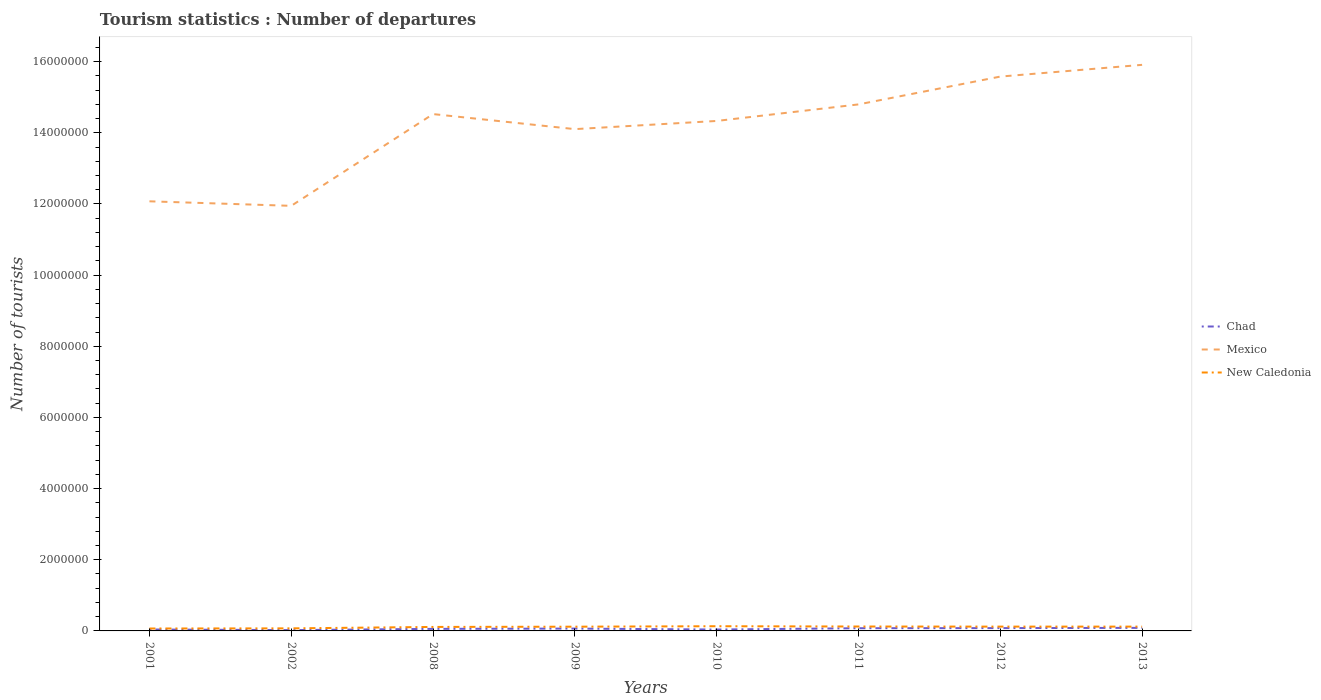How many different coloured lines are there?
Offer a very short reply. 3. Does the line corresponding to Mexico intersect with the line corresponding to New Caledonia?
Your response must be concise. No. Across all years, what is the maximum number of tourist departures in Mexico?
Offer a terse response. 1.19e+07. What is the total number of tourist departures in Mexico in the graph?
Offer a terse response. 4.23e+05. What is the difference between the highest and the second highest number of tourist departures in New Caledonia?
Make the answer very short. 6.40e+04. What is the difference between the highest and the lowest number of tourist departures in Mexico?
Your response must be concise. 5. What is the difference between two consecutive major ticks on the Y-axis?
Provide a short and direct response. 2.00e+06. How are the legend labels stacked?
Provide a short and direct response. Vertical. What is the title of the graph?
Your answer should be compact. Tourism statistics : Number of departures. Does "Aruba" appear as one of the legend labels in the graph?
Offer a very short reply. No. What is the label or title of the Y-axis?
Keep it short and to the point. Number of tourists. What is the Number of tourists in Mexico in 2001?
Provide a succinct answer. 1.21e+07. What is the Number of tourists of New Caledonia in 2001?
Offer a very short reply. 6.80e+04. What is the Number of tourists in Chad in 2002?
Keep it short and to the point. 2.30e+04. What is the Number of tourists of Mexico in 2002?
Your answer should be very brief. 1.19e+07. What is the Number of tourists in New Caledonia in 2002?
Your answer should be compact. 7.20e+04. What is the Number of tourists in Chad in 2008?
Your response must be concise. 5.80e+04. What is the Number of tourists in Mexico in 2008?
Your response must be concise. 1.45e+07. What is the Number of tourists of New Caledonia in 2008?
Provide a short and direct response. 1.12e+05. What is the Number of tourists of Chad in 2009?
Your answer should be compact. 6.60e+04. What is the Number of tourists in Mexico in 2009?
Make the answer very short. 1.41e+07. What is the Number of tourists of New Caledonia in 2009?
Your answer should be very brief. 1.19e+05. What is the Number of tourists in Chad in 2010?
Provide a succinct answer. 3.90e+04. What is the Number of tourists of Mexico in 2010?
Your answer should be compact. 1.43e+07. What is the Number of tourists of New Caledonia in 2010?
Your response must be concise. 1.32e+05. What is the Number of tourists in Chad in 2011?
Make the answer very short. 7.60e+04. What is the Number of tourists in Mexico in 2011?
Offer a very short reply. 1.48e+07. What is the Number of tourists in New Caledonia in 2011?
Provide a short and direct response. 1.24e+05. What is the Number of tourists of Chad in 2012?
Offer a very short reply. 7.90e+04. What is the Number of tourists of Mexico in 2012?
Provide a short and direct response. 1.56e+07. What is the Number of tourists in New Caledonia in 2012?
Provide a succinct answer. 1.21e+05. What is the Number of tourists in Chad in 2013?
Ensure brevity in your answer.  8.60e+04. What is the Number of tourists of Mexico in 2013?
Your answer should be very brief. 1.59e+07. What is the Number of tourists in New Caledonia in 2013?
Provide a succinct answer. 1.21e+05. Across all years, what is the maximum Number of tourists in Chad?
Offer a very short reply. 8.60e+04. Across all years, what is the maximum Number of tourists of Mexico?
Offer a terse response. 1.59e+07. Across all years, what is the maximum Number of tourists in New Caledonia?
Provide a succinct answer. 1.32e+05. Across all years, what is the minimum Number of tourists in Chad?
Provide a short and direct response. 2.30e+04. Across all years, what is the minimum Number of tourists in Mexico?
Ensure brevity in your answer.  1.19e+07. Across all years, what is the minimum Number of tourists in New Caledonia?
Make the answer very short. 6.80e+04. What is the total Number of tourists of Chad in the graph?
Offer a terse response. 4.67e+05. What is the total Number of tourists of Mexico in the graph?
Ensure brevity in your answer.  1.13e+08. What is the total Number of tourists in New Caledonia in the graph?
Provide a short and direct response. 8.69e+05. What is the difference between the Number of tourists in Chad in 2001 and that in 2002?
Make the answer very short. 1.70e+04. What is the difference between the Number of tourists in Mexico in 2001 and that in 2002?
Offer a terse response. 1.27e+05. What is the difference between the Number of tourists in New Caledonia in 2001 and that in 2002?
Provide a succinct answer. -4000. What is the difference between the Number of tourists of Chad in 2001 and that in 2008?
Provide a short and direct response. -1.80e+04. What is the difference between the Number of tourists of Mexico in 2001 and that in 2008?
Provide a succinct answer. -2.45e+06. What is the difference between the Number of tourists in New Caledonia in 2001 and that in 2008?
Provide a succinct answer. -4.40e+04. What is the difference between the Number of tourists in Chad in 2001 and that in 2009?
Offer a terse response. -2.60e+04. What is the difference between the Number of tourists in Mexico in 2001 and that in 2009?
Ensure brevity in your answer.  -2.03e+06. What is the difference between the Number of tourists in New Caledonia in 2001 and that in 2009?
Provide a short and direct response. -5.10e+04. What is the difference between the Number of tourists of Mexico in 2001 and that in 2010?
Keep it short and to the point. -2.26e+06. What is the difference between the Number of tourists in New Caledonia in 2001 and that in 2010?
Provide a short and direct response. -6.40e+04. What is the difference between the Number of tourists in Chad in 2001 and that in 2011?
Ensure brevity in your answer.  -3.60e+04. What is the difference between the Number of tourists in Mexico in 2001 and that in 2011?
Your answer should be very brief. -2.72e+06. What is the difference between the Number of tourists of New Caledonia in 2001 and that in 2011?
Ensure brevity in your answer.  -5.60e+04. What is the difference between the Number of tourists in Chad in 2001 and that in 2012?
Give a very brief answer. -3.90e+04. What is the difference between the Number of tourists of Mexico in 2001 and that in 2012?
Make the answer very short. -3.51e+06. What is the difference between the Number of tourists in New Caledonia in 2001 and that in 2012?
Give a very brief answer. -5.30e+04. What is the difference between the Number of tourists in Chad in 2001 and that in 2013?
Offer a very short reply. -4.60e+04. What is the difference between the Number of tourists of Mexico in 2001 and that in 2013?
Your answer should be very brief. -3.84e+06. What is the difference between the Number of tourists of New Caledonia in 2001 and that in 2013?
Offer a terse response. -5.30e+04. What is the difference between the Number of tourists of Chad in 2002 and that in 2008?
Your response must be concise. -3.50e+04. What is the difference between the Number of tourists of Mexico in 2002 and that in 2008?
Ensure brevity in your answer.  -2.58e+06. What is the difference between the Number of tourists in New Caledonia in 2002 and that in 2008?
Your response must be concise. -4.00e+04. What is the difference between the Number of tourists of Chad in 2002 and that in 2009?
Your answer should be compact. -4.30e+04. What is the difference between the Number of tourists of Mexico in 2002 and that in 2009?
Keep it short and to the point. -2.16e+06. What is the difference between the Number of tourists of New Caledonia in 2002 and that in 2009?
Offer a terse response. -4.70e+04. What is the difference between the Number of tourists of Chad in 2002 and that in 2010?
Keep it short and to the point. -1.60e+04. What is the difference between the Number of tourists in Mexico in 2002 and that in 2010?
Your answer should be compact. -2.39e+06. What is the difference between the Number of tourists in New Caledonia in 2002 and that in 2010?
Offer a terse response. -6.00e+04. What is the difference between the Number of tourists in Chad in 2002 and that in 2011?
Keep it short and to the point. -5.30e+04. What is the difference between the Number of tourists in Mexico in 2002 and that in 2011?
Give a very brief answer. -2.85e+06. What is the difference between the Number of tourists in New Caledonia in 2002 and that in 2011?
Make the answer very short. -5.20e+04. What is the difference between the Number of tourists in Chad in 2002 and that in 2012?
Ensure brevity in your answer.  -5.60e+04. What is the difference between the Number of tourists of Mexico in 2002 and that in 2012?
Ensure brevity in your answer.  -3.63e+06. What is the difference between the Number of tourists in New Caledonia in 2002 and that in 2012?
Give a very brief answer. -4.90e+04. What is the difference between the Number of tourists in Chad in 2002 and that in 2013?
Ensure brevity in your answer.  -6.30e+04. What is the difference between the Number of tourists of Mexico in 2002 and that in 2013?
Your answer should be compact. -3.96e+06. What is the difference between the Number of tourists in New Caledonia in 2002 and that in 2013?
Offer a terse response. -4.90e+04. What is the difference between the Number of tourists in Chad in 2008 and that in 2009?
Make the answer very short. -8000. What is the difference between the Number of tourists of Mexico in 2008 and that in 2009?
Give a very brief answer. 4.23e+05. What is the difference between the Number of tourists of New Caledonia in 2008 and that in 2009?
Keep it short and to the point. -7000. What is the difference between the Number of tourists in Chad in 2008 and that in 2010?
Provide a short and direct response. 1.90e+04. What is the difference between the Number of tourists in Mexico in 2008 and that in 2010?
Give a very brief answer. 1.93e+05. What is the difference between the Number of tourists of New Caledonia in 2008 and that in 2010?
Keep it short and to the point. -2.00e+04. What is the difference between the Number of tourists of Chad in 2008 and that in 2011?
Make the answer very short. -1.80e+04. What is the difference between the Number of tourists of Mexico in 2008 and that in 2011?
Make the answer very short. -2.72e+05. What is the difference between the Number of tourists in New Caledonia in 2008 and that in 2011?
Provide a short and direct response. -1.20e+04. What is the difference between the Number of tourists of Chad in 2008 and that in 2012?
Your response must be concise. -2.10e+04. What is the difference between the Number of tourists in Mexico in 2008 and that in 2012?
Ensure brevity in your answer.  -1.05e+06. What is the difference between the Number of tourists in New Caledonia in 2008 and that in 2012?
Provide a short and direct response. -9000. What is the difference between the Number of tourists in Chad in 2008 and that in 2013?
Provide a succinct answer. -2.80e+04. What is the difference between the Number of tourists of Mexico in 2008 and that in 2013?
Keep it short and to the point. -1.38e+06. What is the difference between the Number of tourists of New Caledonia in 2008 and that in 2013?
Offer a very short reply. -9000. What is the difference between the Number of tourists of Chad in 2009 and that in 2010?
Provide a short and direct response. 2.70e+04. What is the difference between the Number of tourists of Mexico in 2009 and that in 2010?
Ensure brevity in your answer.  -2.30e+05. What is the difference between the Number of tourists in New Caledonia in 2009 and that in 2010?
Provide a succinct answer. -1.30e+04. What is the difference between the Number of tourists in Chad in 2009 and that in 2011?
Provide a succinct answer. -10000. What is the difference between the Number of tourists of Mexico in 2009 and that in 2011?
Your answer should be compact. -6.95e+05. What is the difference between the Number of tourists in New Caledonia in 2009 and that in 2011?
Your answer should be compact. -5000. What is the difference between the Number of tourists of Chad in 2009 and that in 2012?
Make the answer very short. -1.30e+04. What is the difference between the Number of tourists in Mexico in 2009 and that in 2012?
Keep it short and to the point. -1.48e+06. What is the difference between the Number of tourists of New Caledonia in 2009 and that in 2012?
Your answer should be compact. -2000. What is the difference between the Number of tourists in Chad in 2009 and that in 2013?
Ensure brevity in your answer.  -2.00e+04. What is the difference between the Number of tourists of Mexico in 2009 and that in 2013?
Make the answer very short. -1.81e+06. What is the difference between the Number of tourists in New Caledonia in 2009 and that in 2013?
Make the answer very short. -2000. What is the difference between the Number of tourists in Chad in 2010 and that in 2011?
Your answer should be compact. -3.70e+04. What is the difference between the Number of tourists in Mexico in 2010 and that in 2011?
Your answer should be compact. -4.65e+05. What is the difference between the Number of tourists of New Caledonia in 2010 and that in 2011?
Give a very brief answer. 8000. What is the difference between the Number of tourists in Chad in 2010 and that in 2012?
Your answer should be very brief. -4.00e+04. What is the difference between the Number of tourists in Mexico in 2010 and that in 2012?
Offer a terse response. -1.25e+06. What is the difference between the Number of tourists of New Caledonia in 2010 and that in 2012?
Ensure brevity in your answer.  1.10e+04. What is the difference between the Number of tourists in Chad in 2010 and that in 2013?
Your answer should be compact. -4.70e+04. What is the difference between the Number of tourists in Mexico in 2010 and that in 2013?
Give a very brief answer. -1.58e+06. What is the difference between the Number of tourists of New Caledonia in 2010 and that in 2013?
Give a very brief answer. 1.10e+04. What is the difference between the Number of tourists in Chad in 2011 and that in 2012?
Offer a terse response. -3000. What is the difference between the Number of tourists in Mexico in 2011 and that in 2012?
Keep it short and to the point. -7.82e+05. What is the difference between the Number of tourists of New Caledonia in 2011 and that in 2012?
Your response must be concise. 3000. What is the difference between the Number of tourists of Mexico in 2011 and that in 2013?
Provide a succinct answer. -1.11e+06. What is the difference between the Number of tourists in New Caledonia in 2011 and that in 2013?
Ensure brevity in your answer.  3000. What is the difference between the Number of tourists in Chad in 2012 and that in 2013?
Provide a short and direct response. -7000. What is the difference between the Number of tourists in Mexico in 2012 and that in 2013?
Your answer should be very brief. -3.30e+05. What is the difference between the Number of tourists in New Caledonia in 2012 and that in 2013?
Offer a very short reply. 0. What is the difference between the Number of tourists in Chad in 2001 and the Number of tourists in Mexico in 2002?
Make the answer very short. -1.19e+07. What is the difference between the Number of tourists in Chad in 2001 and the Number of tourists in New Caledonia in 2002?
Your response must be concise. -3.20e+04. What is the difference between the Number of tourists of Mexico in 2001 and the Number of tourists of New Caledonia in 2002?
Give a very brief answer. 1.20e+07. What is the difference between the Number of tourists in Chad in 2001 and the Number of tourists in Mexico in 2008?
Ensure brevity in your answer.  -1.45e+07. What is the difference between the Number of tourists of Chad in 2001 and the Number of tourists of New Caledonia in 2008?
Keep it short and to the point. -7.20e+04. What is the difference between the Number of tourists in Mexico in 2001 and the Number of tourists in New Caledonia in 2008?
Offer a very short reply. 1.20e+07. What is the difference between the Number of tourists of Chad in 2001 and the Number of tourists of Mexico in 2009?
Your response must be concise. -1.41e+07. What is the difference between the Number of tourists in Chad in 2001 and the Number of tourists in New Caledonia in 2009?
Provide a succinct answer. -7.90e+04. What is the difference between the Number of tourists in Mexico in 2001 and the Number of tourists in New Caledonia in 2009?
Ensure brevity in your answer.  1.20e+07. What is the difference between the Number of tourists of Chad in 2001 and the Number of tourists of Mexico in 2010?
Provide a short and direct response. -1.43e+07. What is the difference between the Number of tourists of Chad in 2001 and the Number of tourists of New Caledonia in 2010?
Offer a terse response. -9.20e+04. What is the difference between the Number of tourists of Mexico in 2001 and the Number of tourists of New Caledonia in 2010?
Make the answer very short. 1.19e+07. What is the difference between the Number of tourists of Chad in 2001 and the Number of tourists of Mexico in 2011?
Give a very brief answer. -1.48e+07. What is the difference between the Number of tourists in Chad in 2001 and the Number of tourists in New Caledonia in 2011?
Provide a succinct answer. -8.40e+04. What is the difference between the Number of tourists in Mexico in 2001 and the Number of tourists in New Caledonia in 2011?
Provide a succinct answer. 1.20e+07. What is the difference between the Number of tourists of Chad in 2001 and the Number of tourists of Mexico in 2012?
Provide a succinct answer. -1.55e+07. What is the difference between the Number of tourists of Chad in 2001 and the Number of tourists of New Caledonia in 2012?
Ensure brevity in your answer.  -8.10e+04. What is the difference between the Number of tourists of Mexico in 2001 and the Number of tourists of New Caledonia in 2012?
Your answer should be very brief. 1.20e+07. What is the difference between the Number of tourists in Chad in 2001 and the Number of tourists in Mexico in 2013?
Offer a terse response. -1.59e+07. What is the difference between the Number of tourists of Chad in 2001 and the Number of tourists of New Caledonia in 2013?
Your answer should be very brief. -8.10e+04. What is the difference between the Number of tourists of Mexico in 2001 and the Number of tourists of New Caledonia in 2013?
Your answer should be compact. 1.20e+07. What is the difference between the Number of tourists in Chad in 2002 and the Number of tourists in Mexico in 2008?
Offer a very short reply. -1.45e+07. What is the difference between the Number of tourists of Chad in 2002 and the Number of tourists of New Caledonia in 2008?
Keep it short and to the point. -8.90e+04. What is the difference between the Number of tourists in Mexico in 2002 and the Number of tourists in New Caledonia in 2008?
Keep it short and to the point. 1.18e+07. What is the difference between the Number of tourists in Chad in 2002 and the Number of tourists in Mexico in 2009?
Provide a succinct answer. -1.41e+07. What is the difference between the Number of tourists in Chad in 2002 and the Number of tourists in New Caledonia in 2009?
Keep it short and to the point. -9.60e+04. What is the difference between the Number of tourists in Mexico in 2002 and the Number of tourists in New Caledonia in 2009?
Offer a very short reply. 1.18e+07. What is the difference between the Number of tourists of Chad in 2002 and the Number of tourists of Mexico in 2010?
Your answer should be very brief. -1.43e+07. What is the difference between the Number of tourists of Chad in 2002 and the Number of tourists of New Caledonia in 2010?
Keep it short and to the point. -1.09e+05. What is the difference between the Number of tourists in Mexico in 2002 and the Number of tourists in New Caledonia in 2010?
Your response must be concise. 1.18e+07. What is the difference between the Number of tourists in Chad in 2002 and the Number of tourists in Mexico in 2011?
Ensure brevity in your answer.  -1.48e+07. What is the difference between the Number of tourists in Chad in 2002 and the Number of tourists in New Caledonia in 2011?
Offer a terse response. -1.01e+05. What is the difference between the Number of tourists in Mexico in 2002 and the Number of tourists in New Caledonia in 2011?
Your response must be concise. 1.18e+07. What is the difference between the Number of tourists in Chad in 2002 and the Number of tourists in Mexico in 2012?
Your answer should be very brief. -1.56e+07. What is the difference between the Number of tourists in Chad in 2002 and the Number of tourists in New Caledonia in 2012?
Offer a terse response. -9.80e+04. What is the difference between the Number of tourists of Mexico in 2002 and the Number of tourists of New Caledonia in 2012?
Offer a terse response. 1.18e+07. What is the difference between the Number of tourists of Chad in 2002 and the Number of tourists of Mexico in 2013?
Make the answer very short. -1.59e+07. What is the difference between the Number of tourists of Chad in 2002 and the Number of tourists of New Caledonia in 2013?
Your answer should be compact. -9.80e+04. What is the difference between the Number of tourists of Mexico in 2002 and the Number of tourists of New Caledonia in 2013?
Your answer should be very brief. 1.18e+07. What is the difference between the Number of tourists in Chad in 2008 and the Number of tourists in Mexico in 2009?
Your answer should be very brief. -1.40e+07. What is the difference between the Number of tourists in Chad in 2008 and the Number of tourists in New Caledonia in 2009?
Your answer should be compact. -6.10e+04. What is the difference between the Number of tourists of Mexico in 2008 and the Number of tourists of New Caledonia in 2009?
Give a very brief answer. 1.44e+07. What is the difference between the Number of tourists in Chad in 2008 and the Number of tourists in Mexico in 2010?
Your response must be concise. -1.43e+07. What is the difference between the Number of tourists in Chad in 2008 and the Number of tourists in New Caledonia in 2010?
Your answer should be compact. -7.40e+04. What is the difference between the Number of tourists in Mexico in 2008 and the Number of tourists in New Caledonia in 2010?
Give a very brief answer. 1.44e+07. What is the difference between the Number of tourists of Chad in 2008 and the Number of tourists of Mexico in 2011?
Provide a succinct answer. -1.47e+07. What is the difference between the Number of tourists in Chad in 2008 and the Number of tourists in New Caledonia in 2011?
Your response must be concise. -6.60e+04. What is the difference between the Number of tourists of Mexico in 2008 and the Number of tourists of New Caledonia in 2011?
Provide a short and direct response. 1.44e+07. What is the difference between the Number of tourists in Chad in 2008 and the Number of tourists in Mexico in 2012?
Your answer should be compact. -1.55e+07. What is the difference between the Number of tourists of Chad in 2008 and the Number of tourists of New Caledonia in 2012?
Keep it short and to the point. -6.30e+04. What is the difference between the Number of tourists of Mexico in 2008 and the Number of tourists of New Caledonia in 2012?
Give a very brief answer. 1.44e+07. What is the difference between the Number of tourists of Chad in 2008 and the Number of tourists of Mexico in 2013?
Ensure brevity in your answer.  -1.59e+07. What is the difference between the Number of tourists in Chad in 2008 and the Number of tourists in New Caledonia in 2013?
Your response must be concise. -6.30e+04. What is the difference between the Number of tourists of Mexico in 2008 and the Number of tourists of New Caledonia in 2013?
Ensure brevity in your answer.  1.44e+07. What is the difference between the Number of tourists of Chad in 2009 and the Number of tourists of Mexico in 2010?
Offer a terse response. -1.43e+07. What is the difference between the Number of tourists in Chad in 2009 and the Number of tourists in New Caledonia in 2010?
Ensure brevity in your answer.  -6.60e+04. What is the difference between the Number of tourists in Mexico in 2009 and the Number of tourists in New Caledonia in 2010?
Your answer should be very brief. 1.40e+07. What is the difference between the Number of tourists of Chad in 2009 and the Number of tourists of Mexico in 2011?
Provide a succinct answer. -1.47e+07. What is the difference between the Number of tourists of Chad in 2009 and the Number of tourists of New Caledonia in 2011?
Your answer should be very brief. -5.80e+04. What is the difference between the Number of tourists in Mexico in 2009 and the Number of tourists in New Caledonia in 2011?
Provide a succinct answer. 1.40e+07. What is the difference between the Number of tourists in Chad in 2009 and the Number of tourists in Mexico in 2012?
Offer a terse response. -1.55e+07. What is the difference between the Number of tourists in Chad in 2009 and the Number of tourists in New Caledonia in 2012?
Ensure brevity in your answer.  -5.50e+04. What is the difference between the Number of tourists in Mexico in 2009 and the Number of tourists in New Caledonia in 2012?
Your response must be concise. 1.40e+07. What is the difference between the Number of tourists of Chad in 2009 and the Number of tourists of Mexico in 2013?
Provide a short and direct response. -1.58e+07. What is the difference between the Number of tourists in Chad in 2009 and the Number of tourists in New Caledonia in 2013?
Offer a very short reply. -5.50e+04. What is the difference between the Number of tourists of Mexico in 2009 and the Number of tourists of New Caledonia in 2013?
Your response must be concise. 1.40e+07. What is the difference between the Number of tourists of Chad in 2010 and the Number of tourists of Mexico in 2011?
Provide a short and direct response. -1.48e+07. What is the difference between the Number of tourists in Chad in 2010 and the Number of tourists in New Caledonia in 2011?
Your answer should be compact. -8.50e+04. What is the difference between the Number of tourists of Mexico in 2010 and the Number of tourists of New Caledonia in 2011?
Your answer should be compact. 1.42e+07. What is the difference between the Number of tourists in Chad in 2010 and the Number of tourists in Mexico in 2012?
Your response must be concise. -1.55e+07. What is the difference between the Number of tourists in Chad in 2010 and the Number of tourists in New Caledonia in 2012?
Keep it short and to the point. -8.20e+04. What is the difference between the Number of tourists of Mexico in 2010 and the Number of tourists of New Caledonia in 2012?
Provide a succinct answer. 1.42e+07. What is the difference between the Number of tourists in Chad in 2010 and the Number of tourists in Mexico in 2013?
Make the answer very short. -1.59e+07. What is the difference between the Number of tourists of Chad in 2010 and the Number of tourists of New Caledonia in 2013?
Offer a terse response. -8.20e+04. What is the difference between the Number of tourists in Mexico in 2010 and the Number of tourists in New Caledonia in 2013?
Your answer should be very brief. 1.42e+07. What is the difference between the Number of tourists in Chad in 2011 and the Number of tourists in Mexico in 2012?
Give a very brief answer. -1.55e+07. What is the difference between the Number of tourists of Chad in 2011 and the Number of tourists of New Caledonia in 2012?
Give a very brief answer. -4.50e+04. What is the difference between the Number of tourists of Mexico in 2011 and the Number of tourists of New Caledonia in 2012?
Your answer should be compact. 1.47e+07. What is the difference between the Number of tourists in Chad in 2011 and the Number of tourists in Mexico in 2013?
Give a very brief answer. -1.58e+07. What is the difference between the Number of tourists of Chad in 2011 and the Number of tourists of New Caledonia in 2013?
Ensure brevity in your answer.  -4.50e+04. What is the difference between the Number of tourists in Mexico in 2011 and the Number of tourists in New Caledonia in 2013?
Ensure brevity in your answer.  1.47e+07. What is the difference between the Number of tourists of Chad in 2012 and the Number of tourists of Mexico in 2013?
Offer a very short reply. -1.58e+07. What is the difference between the Number of tourists in Chad in 2012 and the Number of tourists in New Caledonia in 2013?
Provide a succinct answer. -4.20e+04. What is the difference between the Number of tourists of Mexico in 2012 and the Number of tourists of New Caledonia in 2013?
Provide a short and direct response. 1.55e+07. What is the average Number of tourists of Chad per year?
Your answer should be very brief. 5.84e+04. What is the average Number of tourists in Mexico per year?
Ensure brevity in your answer.  1.42e+07. What is the average Number of tourists in New Caledonia per year?
Provide a short and direct response. 1.09e+05. In the year 2001, what is the difference between the Number of tourists of Chad and Number of tourists of Mexico?
Provide a succinct answer. -1.20e+07. In the year 2001, what is the difference between the Number of tourists of Chad and Number of tourists of New Caledonia?
Keep it short and to the point. -2.80e+04. In the year 2001, what is the difference between the Number of tourists of Mexico and Number of tourists of New Caledonia?
Give a very brief answer. 1.20e+07. In the year 2002, what is the difference between the Number of tourists in Chad and Number of tourists in Mexico?
Give a very brief answer. -1.19e+07. In the year 2002, what is the difference between the Number of tourists of Chad and Number of tourists of New Caledonia?
Your answer should be very brief. -4.90e+04. In the year 2002, what is the difference between the Number of tourists in Mexico and Number of tourists in New Caledonia?
Offer a very short reply. 1.19e+07. In the year 2008, what is the difference between the Number of tourists of Chad and Number of tourists of Mexico?
Your response must be concise. -1.45e+07. In the year 2008, what is the difference between the Number of tourists of Chad and Number of tourists of New Caledonia?
Your answer should be very brief. -5.40e+04. In the year 2008, what is the difference between the Number of tourists in Mexico and Number of tourists in New Caledonia?
Make the answer very short. 1.44e+07. In the year 2009, what is the difference between the Number of tourists of Chad and Number of tourists of Mexico?
Provide a short and direct response. -1.40e+07. In the year 2009, what is the difference between the Number of tourists of Chad and Number of tourists of New Caledonia?
Make the answer very short. -5.30e+04. In the year 2009, what is the difference between the Number of tourists in Mexico and Number of tourists in New Caledonia?
Offer a very short reply. 1.40e+07. In the year 2010, what is the difference between the Number of tourists in Chad and Number of tourists in Mexico?
Your response must be concise. -1.43e+07. In the year 2010, what is the difference between the Number of tourists of Chad and Number of tourists of New Caledonia?
Provide a short and direct response. -9.30e+04. In the year 2010, what is the difference between the Number of tourists in Mexico and Number of tourists in New Caledonia?
Provide a short and direct response. 1.42e+07. In the year 2011, what is the difference between the Number of tourists of Chad and Number of tourists of Mexico?
Provide a short and direct response. -1.47e+07. In the year 2011, what is the difference between the Number of tourists in Chad and Number of tourists in New Caledonia?
Offer a terse response. -4.80e+04. In the year 2011, what is the difference between the Number of tourists of Mexico and Number of tourists of New Caledonia?
Offer a terse response. 1.47e+07. In the year 2012, what is the difference between the Number of tourists in Chad and Number of tourists in Mexico?
Make the answer very short. -1.55e+07. In the year 2012, what is the difference between the Number of tourists in Chad and Number of tourists in New Caledonia?
Your answer should be very brief. -4.20e+04. In the year 2012, what is the difference between the Number of tourists of Mexico and Number of tourists of New Caledonia?
Provide a succinct answer. 1.55e+07. In the year 2013, what is the difference between the Number of tourists in Chad and Number of tourists in Mexico?
Make the answer very short. -1.58e+07. In the year 2013, what is the difference between the Number of tourists in Chad and Number of tourists in New Caledonia?
Ensure brevity in your answer.  -3.50e+04. In the year 2013, what is the difference between the Number of tourists in Mexico and Number of tourists in New Caledonia?
Keep it short and to the point. 1.58e+07. What is the ratio of the Number of tourists of Chad in 2001 to that in 2002?
Give a very brief answer. 1.74. What is the ratio of the Number of tourists in Mexico in 2001 to that in 2002?
Your answer should be compact. 1.01. What is the ratio of the Number of tourists in Chad in 2001 to that in 2008?
Your answer should be compact. 0.69. What is the ratio of the Number of tourists in Mexico in 2001 to that in 2008?
Offer a terse response. 0.83. What is the ratio of the Number of tourists in New Caledonia in 2001 to that in 2008?
Offer a terse response. 0.61. What is the ratio of the Number of tourists of Chad in 2001 to that in 2009?
Keep it short and to the point. 0.61. What is the ratio of the Number of tourists of Mexico in 2001 to that in 2009?
Provide a short and direct response. 0.86. What is the ratio of the Number of tourists in New Caledonia in 2001 to that in 2009?
Keep it short and to the point. 0.57. What is the ratio of the Number of tourists of Chad in 2001 to that in 2010?
Ensure brevity in your answer.  1.03. What is the ratio of the Number of tourists in Mexico in 2001 to that in 2010?
Provide a succinct answer. 0.84. What is the ratio of the Number of tourists in New Caledonia in 2001 to that in 2010?
Ensure brevity in your answer.  0.52. What is the ratio of the Number of tourists of Chad in 2001 to that in 2011?
Provide a succinct answer. 0.53. What is the ratio of the Number of tourists in Mexico in 2001 to that in 2011?
Your response must be concise. 0.82. What is the ratio of the Number of tourists in New Caledonia in 2001 to that in 2011?
Offer a terse response. 0.55. What is the ratio of the Number of tourists in Chad in 2001 to that in 2012?
Offer a terse response. 0.51. What is the ratio of the Number of tourists of Mexico in 2001 to that in 2012?
Your answer should be compact. 0.78. What is the ratio of the Number of tourists in New Caledonia in 2001 to that in 2012?
Offer a very short reply. 0.56. What is the ratio of the Number of tourists of Chad in 2001 to that in 2013?
Offer a very short reply. 0.47. What is the ratio of the Number of tourists of Mexico in 2001 to that in 2013?
Ensure brevity in your answer.  0.76. What is the ratio of the Number of tourists of New Caledonia in 2001 to that in 2013?
Keep it short and to the point. 0.56. What is the ratio of the Number of tourists of Chad in 2002 to that in 2008?
Provide a succinct answer. 0.4. What is the ratio of the Number of tourists of Mexico in 2002 to that in 2008?
Your answer should be very brief. 0.82. What is the ratio of the Number of tourists in New Caledonia in 2002 to that in 2008?
Provide a succinct answer. 0.64. What is the ratio of the Number of tourists of Chad in 2002 to that in 2009?
Your answer should be very brief. 0.35. What is the ratio of the Number of tourists in Mexico in 2002 to that in 2009?
Offer a terse response. 0.85. What is the ratio of the Number of tourists in New Caledonia in 2002 to that in 2009?
Your response must be concise. 0.6. What is the ratio of the Number of tourists in Chad in 2002 to that in 2010?
Your response must be concise. 0.59. What is the ratio of the Number of tourists in Mexico in 2002 to that in 2010?
Offer a terse response. 0.83. What is the ratio of the Number of tourists of New Caledonia in 2002 to that in 2010?
Your answer should be compact. 0.55. What is the ratio of the Number of tourists of Chad in 2002 to that in 2011?
Offer a terse response. 0.3. What is the ratio of the Number of tourists of Mexico in 2002 to that in 2011?
Offer a very short reply. 0.81. What is the ratio of the Number of tourists in New Caledonia in 2002 to that in 2011?
Your answer should be very brief. 0.58. What is the ratio of the Number of tourists of Chad in 2002 to that in 2012?
Ensure brevity in your answer.  0.29. What is the ratio of the Number of tourists in Mexico in 2002 to that in 2012?
Make the answer very short. 0.77. What is the ratio of the Number of tourists in New Caledonia in 2002 to that in 2012?
Provide a short and direct response. 0.59. What is the ratio of the Number of tourists in Chad in 2002 to that in 2013?
Offer a terse response. 0.27. What is the ratio of the Number of tourists in Mexico in 2002 to that in 2013?
Ensure brevity in your answer.  0.75. What is the ratio of the Number of tourists of New Caledonia in 2002 to that in 2013?
Make the answer very short. 0.59. What is the ratio of the Number of tourists in Chad in 2008 to that in 2009?
Your response must be concise. 0.88. What is the ratio of the Number of tourists of Mexico in 2008 to that in 2009?
Ensure brevity in your answer.  1.03. What is the ratio of the Number of tourists in Chad in 2008 to that in 2010?
Your answer should be compact. 1.49. What is the ratio of the Number of tourists in Mexico in 2008 to that in 2010?
Make the answer very short. 1.01. What is the ratio of the Number of tourists of New Caledonia in 2008 to that in 2010?
Offer a terse response. 0.85. What is the ratio of the Number of tourists of Chad in 2008 to that in 2011?
Provide a succinct answer. 0.76. What is the ratio of the Number of tourists in Mexico in 2008 to that in 2011?
Offer a terse response. 0.98. What is the ratio of the Number of tourists of New Caledonia in 2008 to that in 2011?
Your answer should be compact. 0.9. What is the ratio of the Number of tourists of Chad in 2008 to that in 2012?
Offer a very short reply. 0.73. What is the ratio of the Number of tourists of Mexico in 2008 to that in 2012?
Your answer should be very brief. 0.93. What is the ratio of the Number of tourists in New Caledonia in 2008 to that in 2012?
Your response must be concise. 0.93. What is the ratio of the Number of tourists in Chad in 2008 to that in 2013?
Make the answer very short. 0.67. What is the ratio of the Number of tourists of New Caledonia in 2008 to that in 2013?
Offer a very short reply. 0.93. What is the ratio of the Number of tourists of Chad in 2009 to that in 2010?
Your answer should be very brief. 1.69. What is the ratio of the Number of tourists in New Caledonia in 2009 to that in 2010?
Make the answer very short. 0.9. What is the ratio of the Number of tourists of Chad in 2009 to that in 2011?
Offer a very short reply. 0.87. What is the ratio of the Number of tourists of Mexico in 2009 to that in 2011?
Keep it short and to the point. 0.95. What is the ratio of the Number of tourists of New Caledonia in 2009 to that in 2011?
Offer a very short reply. 0.96. What is the ratio of the Number of tourists of Chad in 2009 to that in 2012?
Your answer should be compact. 0.84. What is the ratio of the Number of tourists in Mexico in 2009 to that in 2012?
Give a very brief answer. 0.91. What is the ratio of the Number of tourists in New Caledonia in 2009 to that in 2012?
Your response must be concise. 0.98. What is the ratio of the Number of tourists in Chad in 2009 to that in 2013?
Your answer should be very brief. 0.77. What is the ratio of the Number of tourists in Mexico in 2009 to that in 2013?
Keep it short and to the point. 0.89. What is the ratio of the Number of tourists of New Caledonia in 2009 to that in 2013?
Make the answer very short. 0.98. What is the ratio of the Number of tourists of Chad in 2010 to that in 2011?
Give a very brief answer. 0.51. What is the ratio of the Number of tourists in Mexico in 2010 to that in 2011?
Your answer should be very brief. 0.97. What is the ratio of the Number of tourists of New Caledonia in 2010 to that in 2011?
Give a very brief answer. 1.06. What is the ratio of the Number of tourists in Chad in 2010 to that in 2012?
Provide a short and direct response. 0.49. What is the ratio of the Number of tourists of Mexico in 2010 to that in 2012?
Make the answer very short. 0.92. What is the ratio of the Number of tourists of New Caledonia in 2010 to that in 2012?
Give a very brief answer. 1.09. What is the ratio of the Number of tourists in Chad in 2010 to that in 2013?
Offer a terse response. 0.45. What is the ratio of the Number of tourists in Mexico in 2010 to that in 2013?
Your answer should be compact. 0.9. What is the ratio of the Number of tourists of New Caledonia in 2010 to that in 2013?
Give a very brief answer. 1.09. What is the ratio of the Number of tourists of Chad in 2011 to that in 2012?
Give a very brief answer. 0.96. What is the ratio of the Number of tourists in Mexico in 2011 to that in 2012?
Keep it short and to the point. 0.95. What is the ratio of the Number of tourists of New Caledonia in 2011 to that in 2012?
Make the answer very short. 1.02. What is the ratio of the Number of tourists of Chad in 2011 to that in 2013?
Provide a short and direct response. 0.88. What is the ratio of the Number of tourists in Mexico in 2011 to that in 2013?
Give a very brief answer. 0.93. What is the ratio of the Number of tourists in New Caledonia in 2011 to that in 2013?
Provide a succinct answer. 1.02. What is the ratio of the Number of tourists of Chad in 2012 to that in 2013?
Provide a succinct answer. 0.92. What is the ratio of the Number of tourists of Mexico in 2012 to that in 2013?
Provide a short and direct response. 0.98. What is the ratio of the Number of tourists in New Caledonia in 2012 to that in 2013?
Give a very brief answer. 1. What is the difference between the highest and the second highest Number of tourists in Chad?
Offer a terse response. 7000. What is the difference between the highest and the second highest Number of tourists of New Caledonia?
Make the answer very short. 8000. What is the difference between the highest and the lowest Number of tourists in Chad?
Your answer should be compact. 6.30e+04. What is the difference between the highest and the lowest Number of tourists in Mexico?
Offer a terse response. 3.96e+06. What is the difference between the highest and the lowest Number of tourists of New Caledonia?
Your answer should be compact. 6.40e+04. 